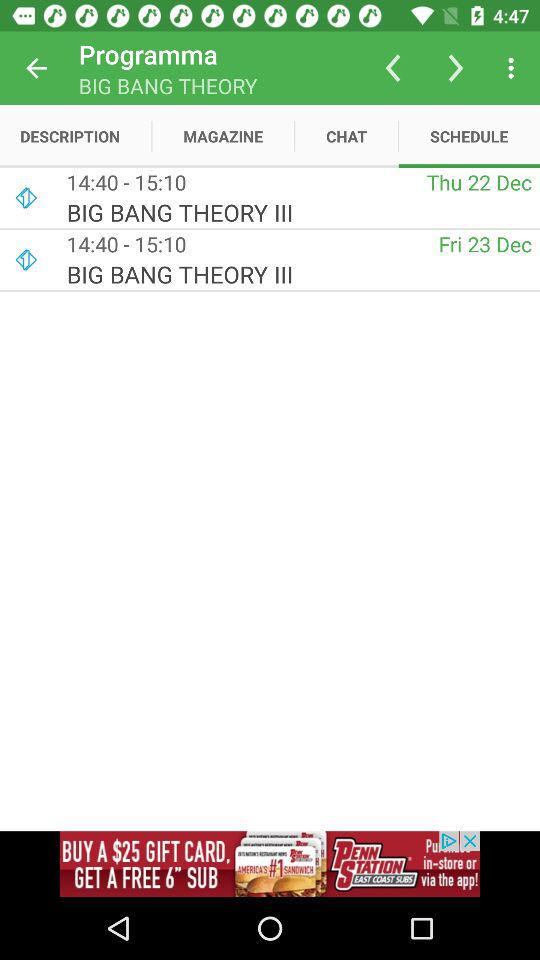What is the schedule of Big Bang Theory lll?
When the provided information is insufficient, respond with <no answer>. <no answer> 